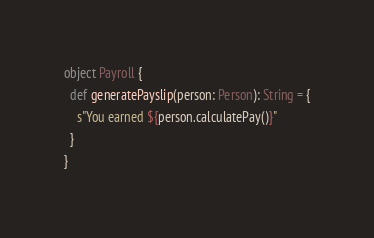Convert code to text. <code><loc_0><loc_0><loc_500><loc_500><_Scala_>
object Payroll {
  def generatePayslip(person: Person): String = {
    s"You earned ${person.calculatePay()}"
  }
}
</code> 